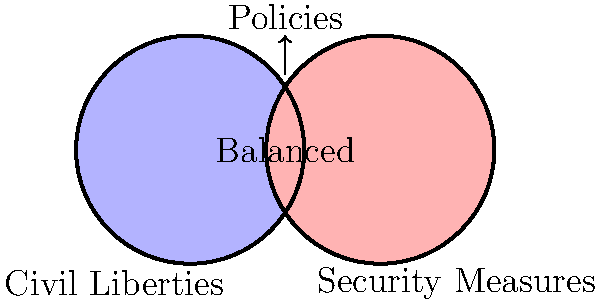In the Venn diagram shown, which area represents the most balanced approach to counterterrorism policies, considering both civil liberties and security measures? To answer this question, let's analyze the Venn diagram step-by-step:

1. The left circle (blue) represents civil liberties.
2. The right circle (red) represents security measures.
3. The overlapping area in the middle represents policies that consider both civil liberties and security measures.

The most balanced approach to counterterrorism policies would be one that considers both civil liberties and security measures equally. This is represented by the overlapping area in the middle of the Venn diagram.

The overlapping area shows:
- It's not entirely focused on civil liberties (it's not completely in the blue circle).
- It's not entirely focused on security measures (it's not completely in the red circle).
- It takes into account both aspects, striking a balance between the two.

This balanced approach is crucial because:
- It ensures that security measures are implemented without completely compromising civil liberties.
- It maintains essential freedoms while still providing necessary protection against terrorism.

The arrow pointing to this overlapping area and labeled "Balanced Policies" further confirms that this is the area representing the most balanced approach to counterterrorism policies.
Answer: The overlapping area in the middle 